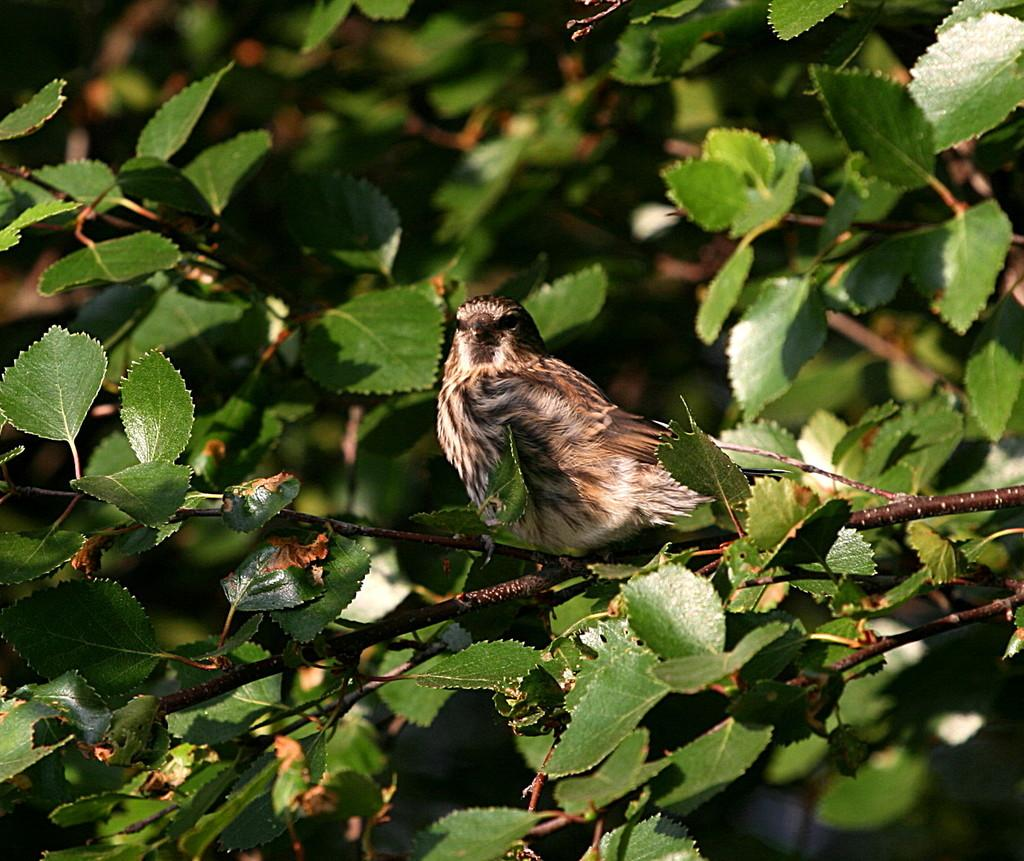What type of animal is present in the image? There is a bird in the image. Where is the bird located? The bird is standing on a tree stem. What can be seen in the background of the image? There are trees with green leaves in the background of the image. What type of alarm is attached to the bird in the image? There is no alarm present in the image; it is a bird standing on a tree stem with trees with green leaves in the background. 